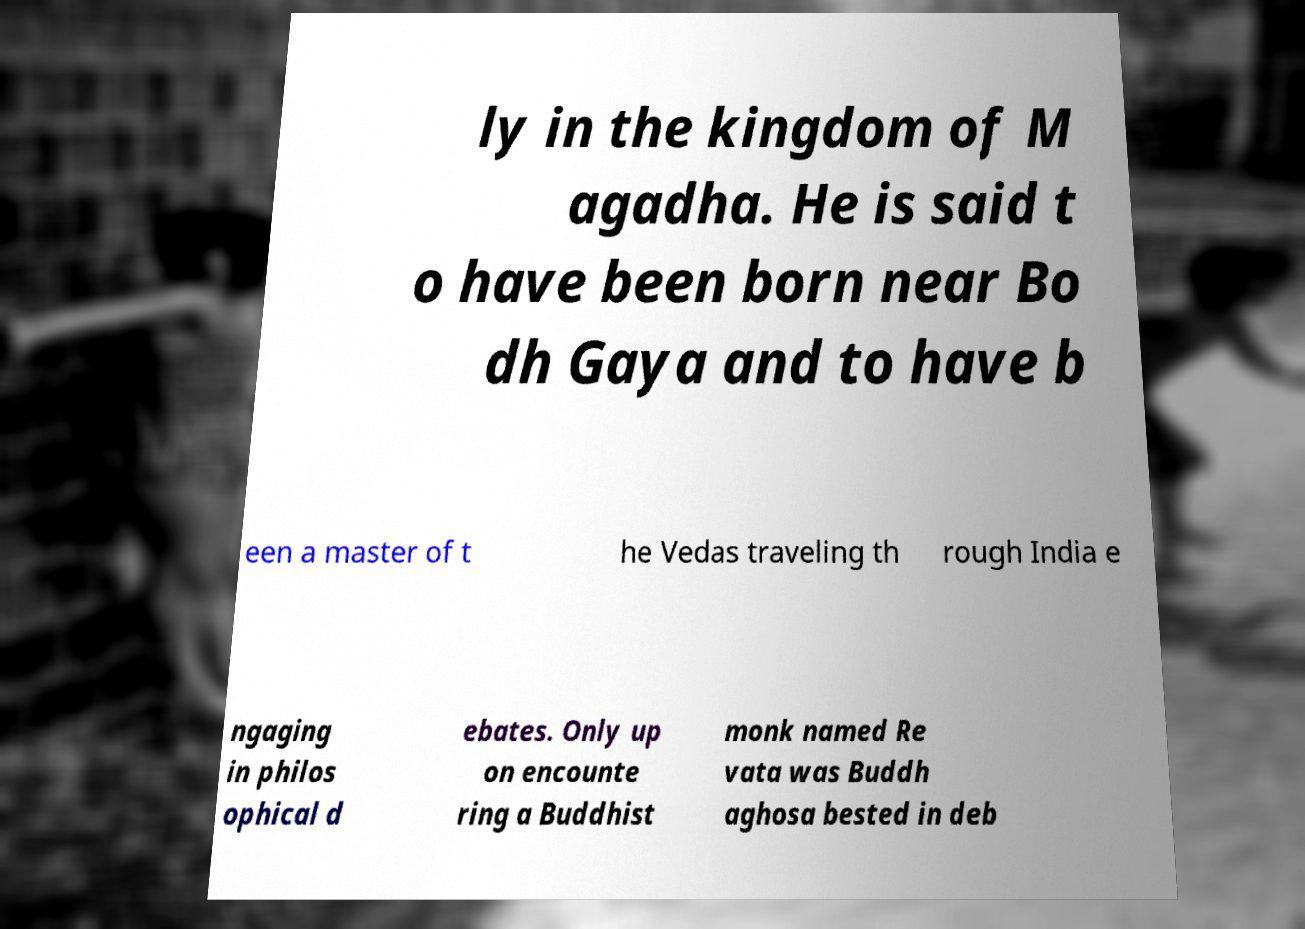Could you extract and type out the text from this image? ly in the kingdom of M agadha. He is said t o have been born near Bo dh Gaya and to have b een a master of t he Vedas traveling th rough India e ngaging in philos ophical d ebates. Only up on encounte ring a Buddhist monk named Re vata was Buddh aghosa bested in deb 